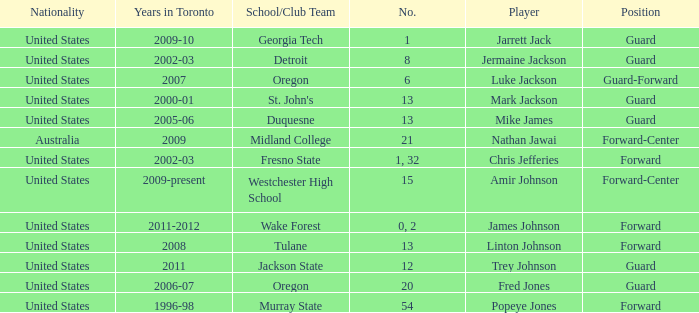Who are all of the players on the Westchester High School club team? Amir Johnson. 